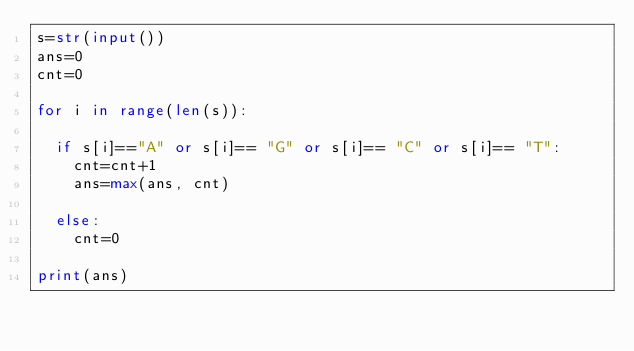Convert code to text. <code><loc_0><loc_0><loc_500><loc_500><_Python_>s=str(input())
ans=0
cnt=0

for i in range(len(s)):
  
  if s[i]=="A" or s[i]== "G" or s[i]== "C" or s[i]== "T":
    cnt=cnt+1
    ans=max(ans, cnt)
    
  else:
    cnt=0
    
print(ans)</code> 